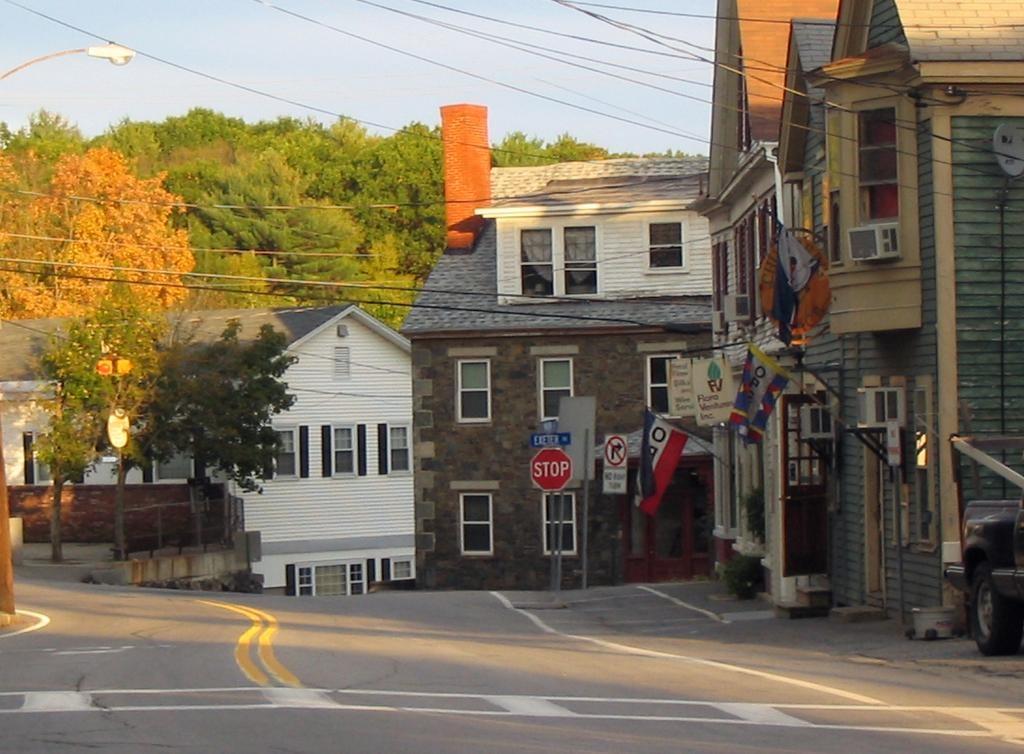What is located at the bottom of the image? There is a road at the bottom of the image. What objects can be seen in the image besides the road? There are boards and buildings in the image. What type of natural elements are visible in the background of the image? There are trees in the background of the image. What is visible at the top of the image? The sky is visible at the top of the image. What type of flower is growing on the sail in the image? There is no flower or sail present in the image. 